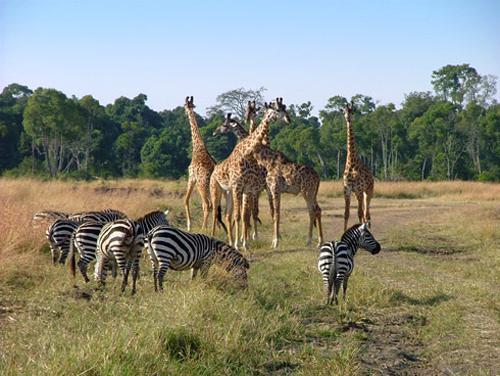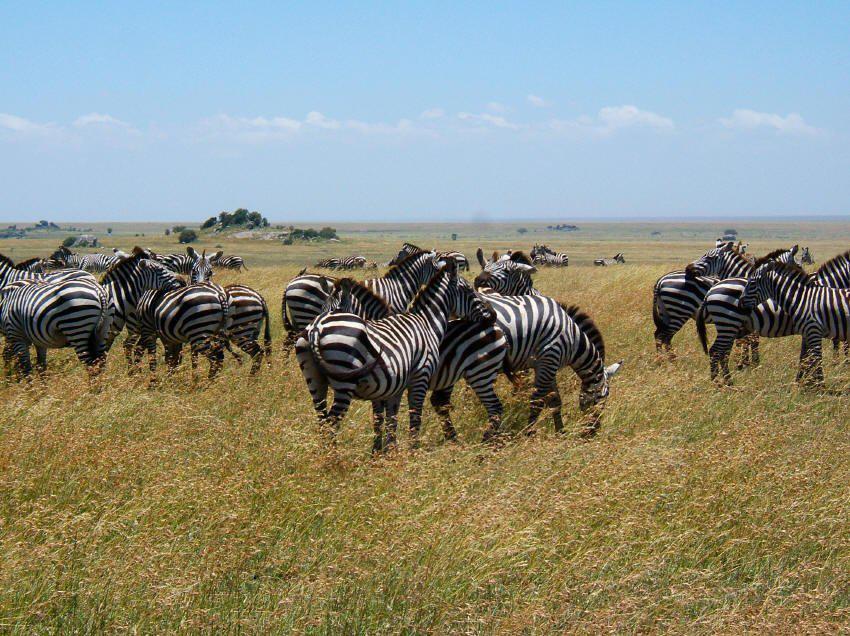The first image is the image on the left, the second image is the image on the right. Analyze the images presented: Is the assertion "IN at least one image there are at least 4 zebras facing away from the camera looking at a different breed of animal." valid? Answer yes or no. Yes. The first image is the image on the left, the second image is the image on the right. For the images displayed, is the sentence "An image shows several zebras with their backs to the camera facing a group of at least five hooved animals belonging to one other species." factually correct? Answer yes or no. Yes. 